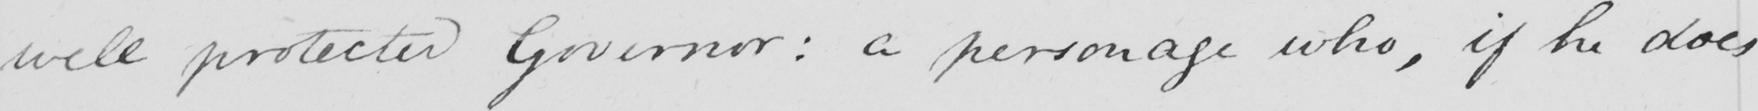What text is written in this handwritten line? well protected Governor :  a personage who , if he does 